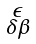<formula> <loc_0><loc_0><loc_500><loc_500>\begin{smallmatrix} \epsilon \\ \delta \beta \end{smallmatrix}</formula> 